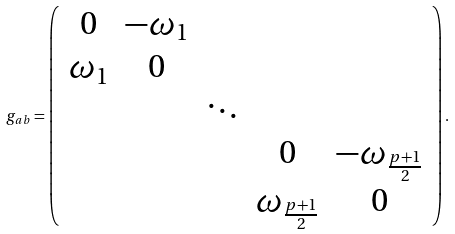<formula> <loc_0><loc_0><loc_500><loc_500>g _ { a b } = \left ( \begin{array} { c c c c c } 0 & - \omega _ { 1 } & & & \\ \omega _ { 1 } & 0 & & & \\ & & \ddots & & \\ & & & 0 & - \omega _ { \frac { p + 1 } { 2 } } \\ & & & \omega _ { \frac { p + 1 } { 2 } } & 0 \\ \end{array} \right ) .</formula> 